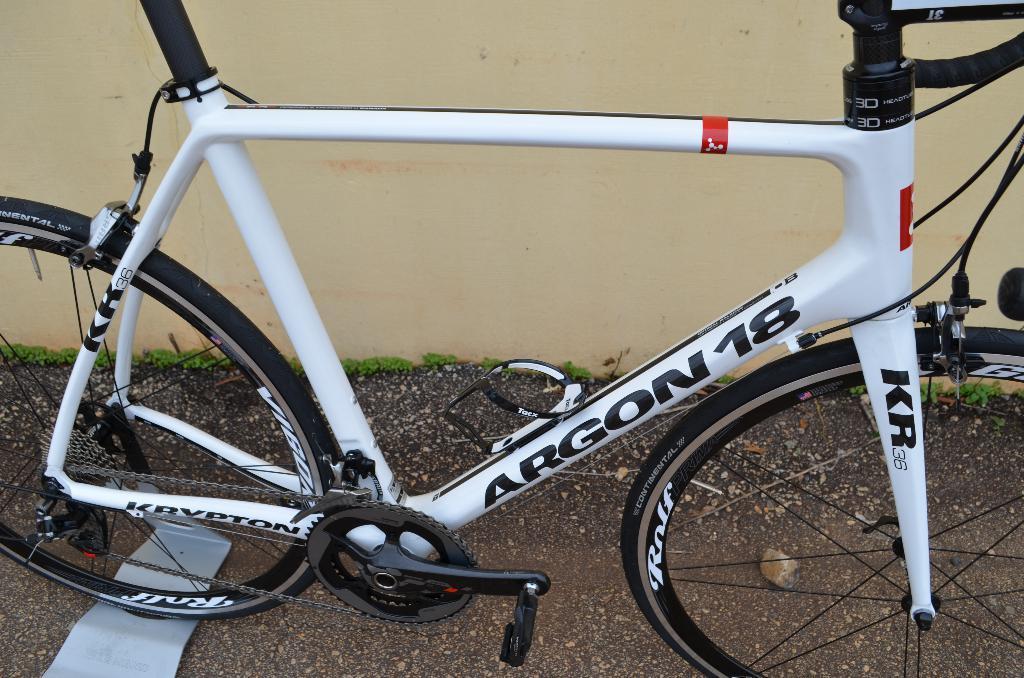In one or two sentences, can you explain what this image depicts? In this picture we can see a bicycle parked on the ground beside a wall. 